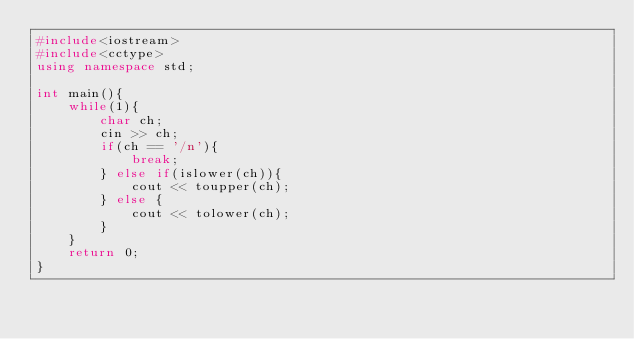Convert code to text. <code><loc_0><loc_0><loc_500><loc_500><_C++_>#include<iostream>
#include<cctype>
using namespace std;

int main(){
    while(1){
        char ch;
        cin >> ch;
        if(ch == '/n'){
            break;
        } else if(islower(ch)){
            cout << toupper(ch);
        } else {
            cout << tolower(ch);
        }
    }
    return 0;
}
</code> 